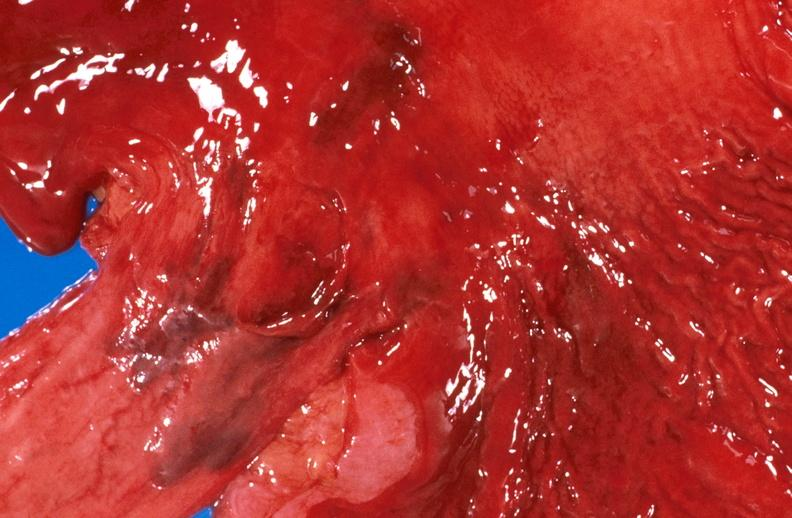s gastrointestinal present?
Answer the question using a single word or phrase. Yes 